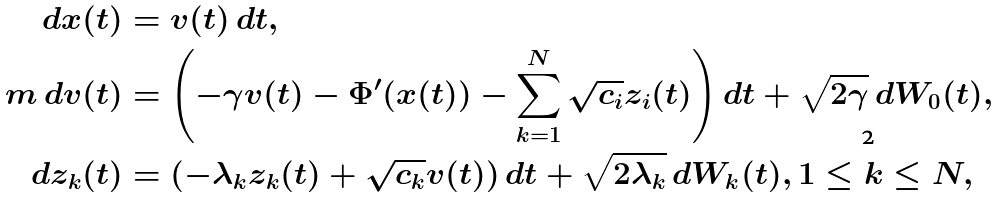<formula> <loc_0><loc_0><loc_500><loc_500>d x ( t ) & = v ( t ) \, d t , \\ m \, d v ( t ) & = \left ( - \gamma v ( t ) - \Phi ^ { \prime } ( x ( t ) ) - \sum _ { k = 1 } ^ { N } \sqrt { c _ { i } } z _ { i } ( t ) \right ) d t + \sqrt { 2 \gamma } \, d W _ { 0 } ( t ) , \\ d z _ { k } ( t ) & = ( - \lambda _ { k } z _ { k } ( t ) + \sqrt { c _ { k } } v ( t ) ) \, d t + \sqrt { 2 \lambda _ { k } } \, d W _ { k } ( t ) , 1 \leq k \leq N , \\</formula> 